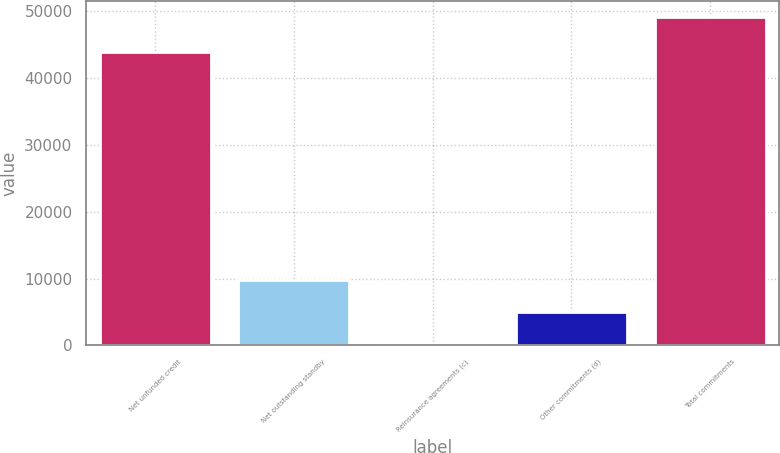Convert chart. <chart><loc_0><loc_0><loc_500><loc_500><bar_chart><fcel>Net unfunded credit<fcel>Net outstanding standby<fcel>Reinsurance agreements (c)<fcel>Other commitments (d)<fcel>Total commitments<nl><fcel>43949<fcel>9853.8<fcel>33<fcel>4943.4<fcel>49137<nl></chart> 